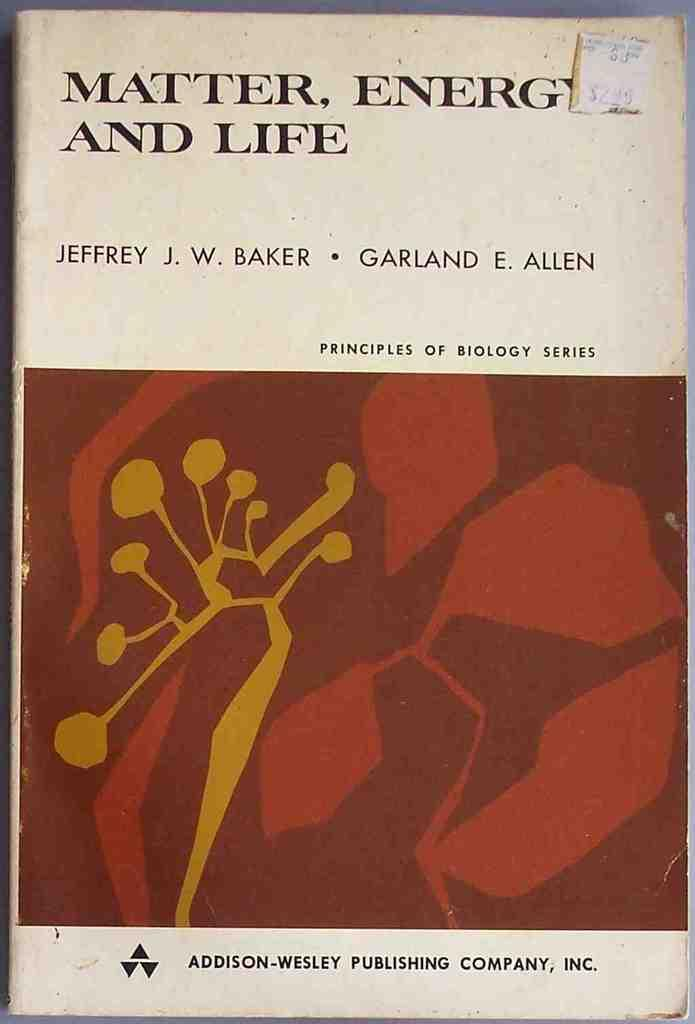<image>
Provide a brief description of the given image. the cover of the book Matter, Energy, and Life 